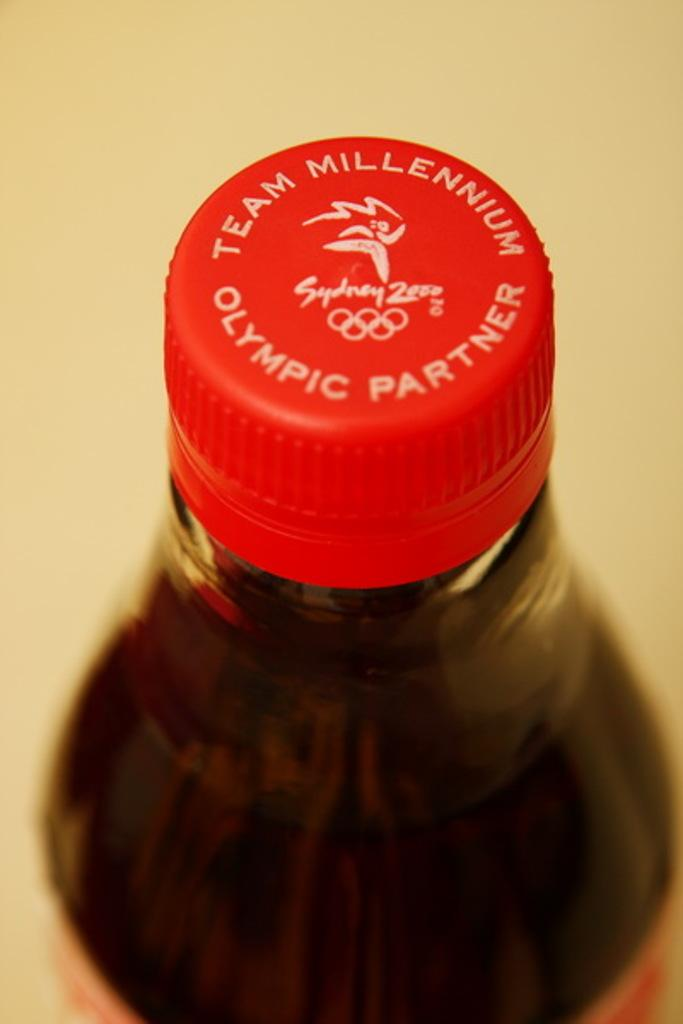<image>
Write a terse but informative summary of the picture. a bottle with a red cap and the words 'team millennium olympic partner' on it 